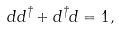<formula> <loc_0><loc_0><loc_500><loc_500>d d ^ { \dagger } + d ^ { \dagger } d = 1 ,</formula> 